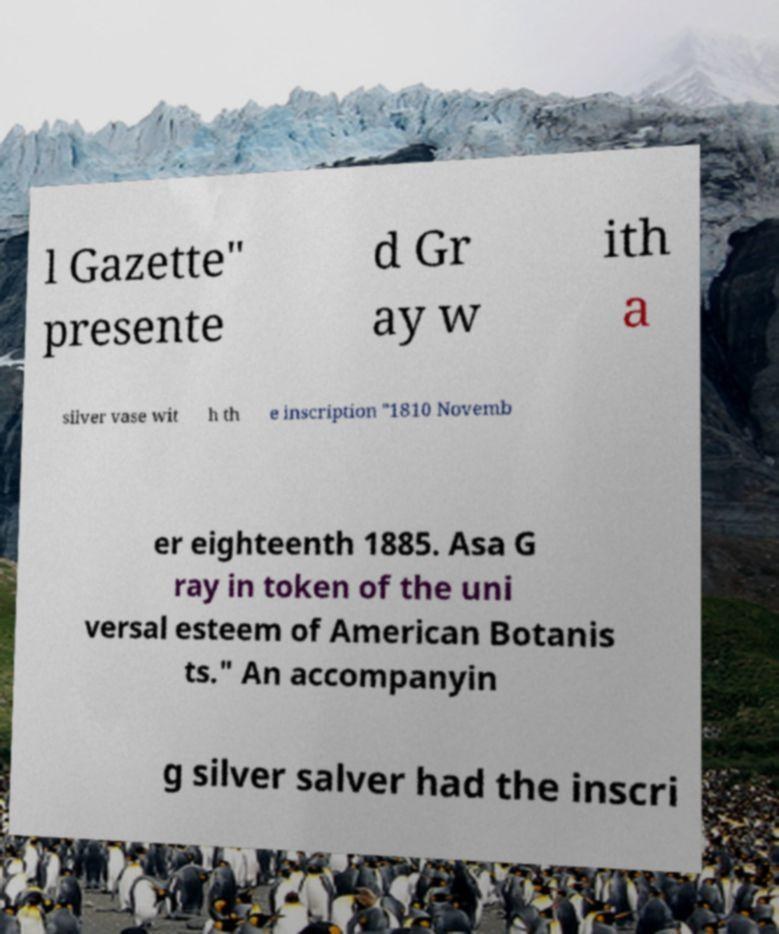Could you assist in decoding the text presented in this image and type it out clearly? l Gazette" presente d Gr ay w ith a silver vase wit h th e inscription "1810 Novemb er eighteenth 1885. Asa G ray in token of the uni versal esteem of American Botanis ts." An accompanyin g silver salver had the inscri 